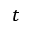Convert formula to latex. <formula><loc_0><loc_0><loc_500><loc_500>t</formula> 